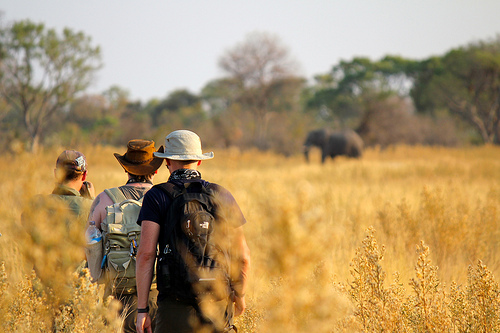What do you notice about the scenery in this image? The scenery appears to be an open plain with dried grass, and there are trees in the background. An elephant is also visible in the distance, and a group of men are walking towards it. The lighting suggests it might be late afternoon or early evening. 